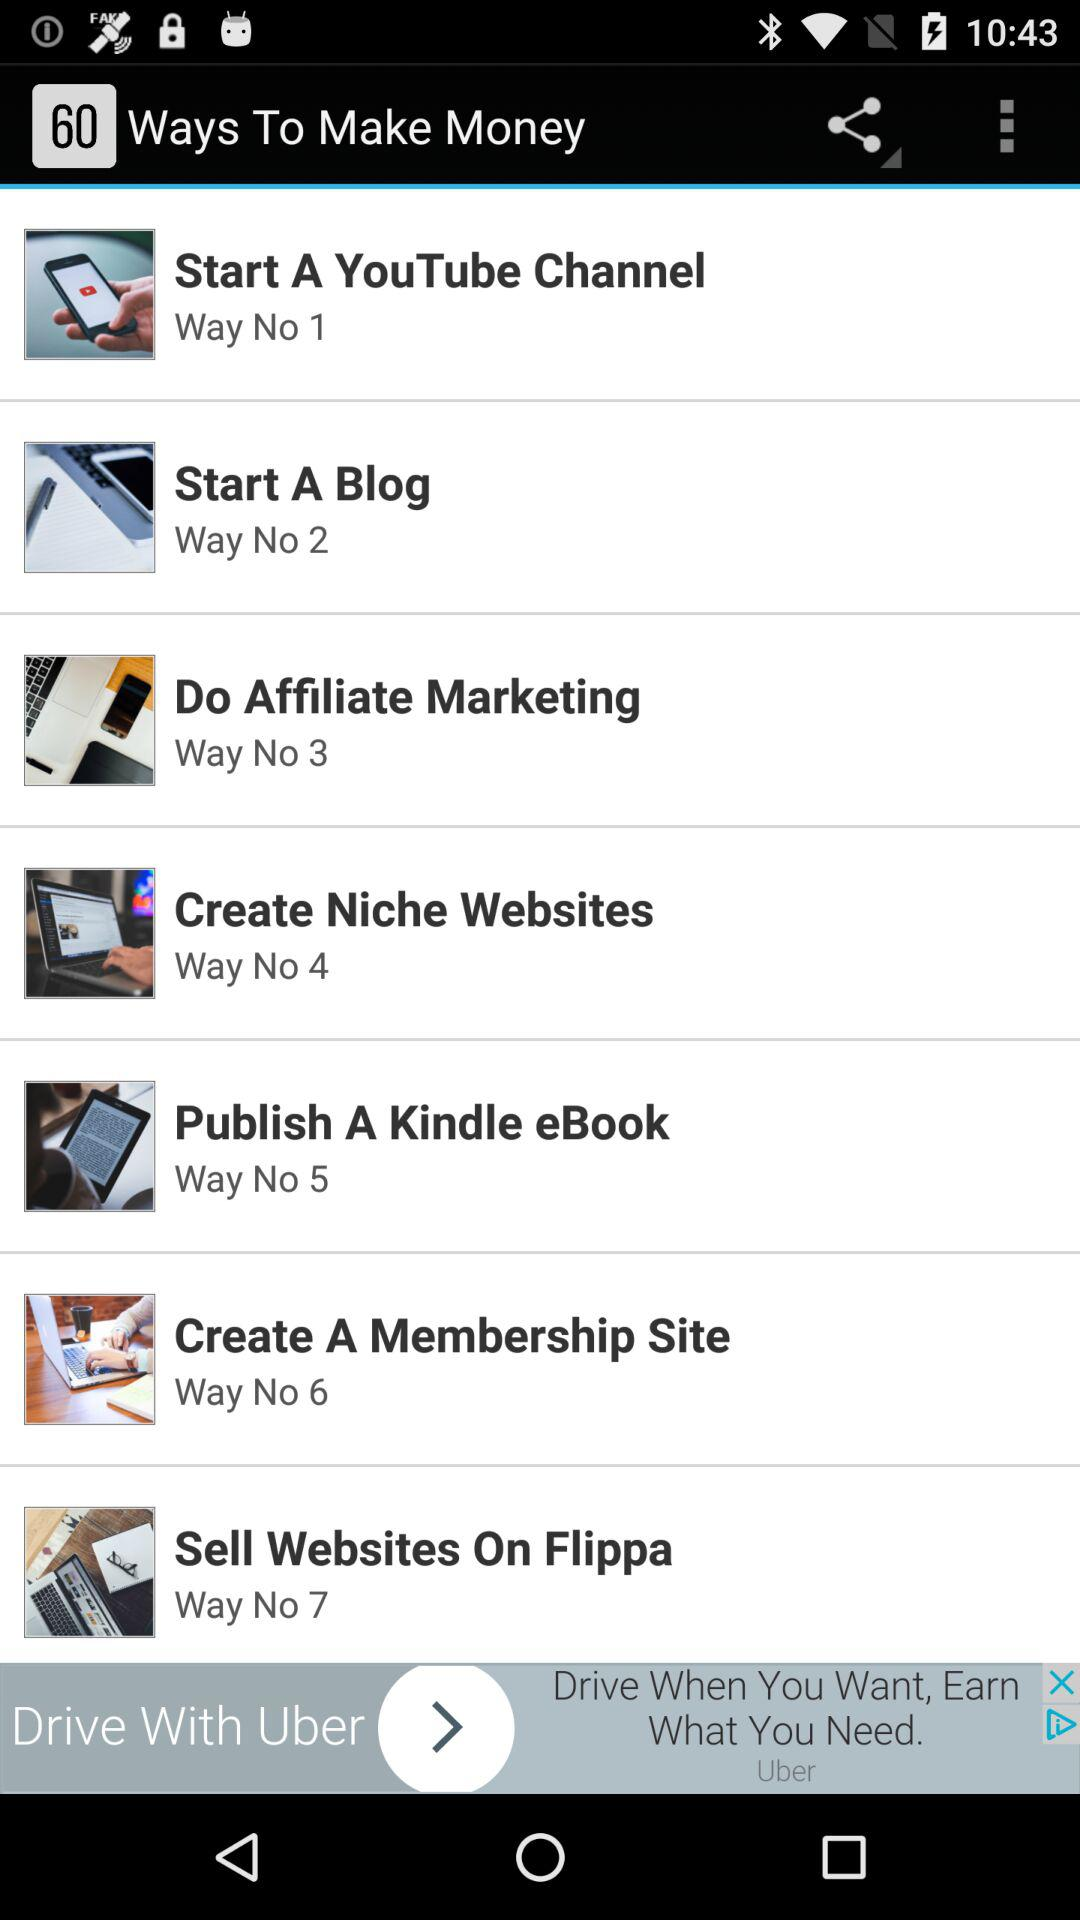What is the first way to make money? The first way to make money is "Start A YouTube Channel". 